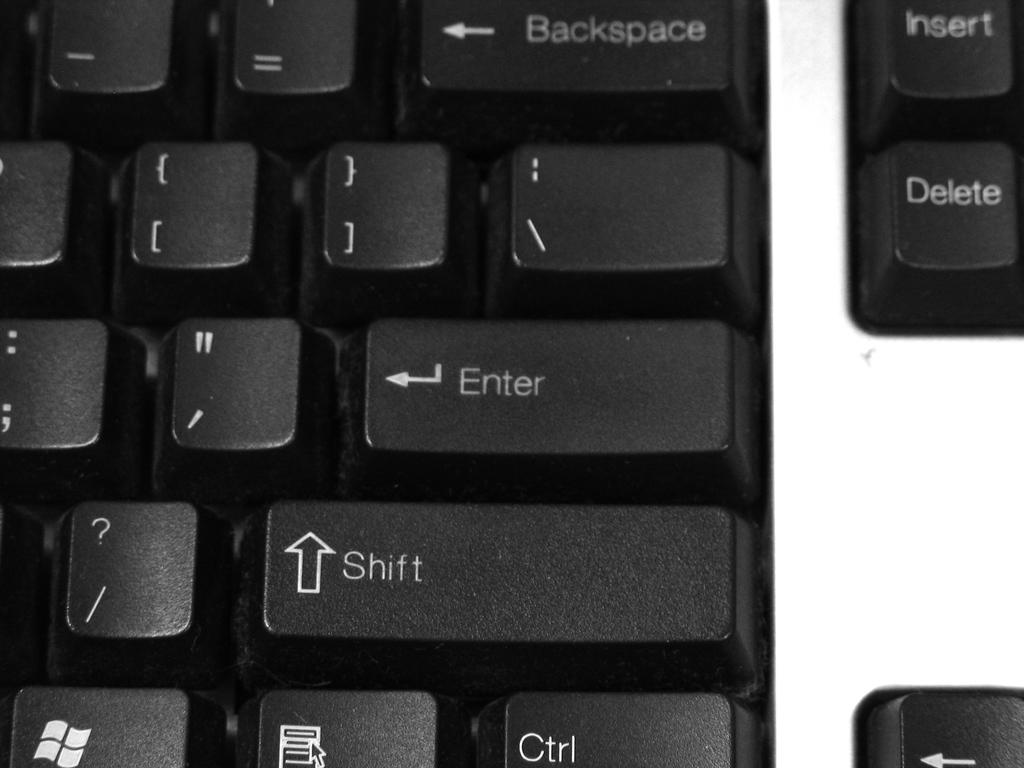What does the key with the up facing arrow called?
Keep it short and to the point. Shift. What is the function of the key in the top right corner?
Provide a short and direct response. Insert. 